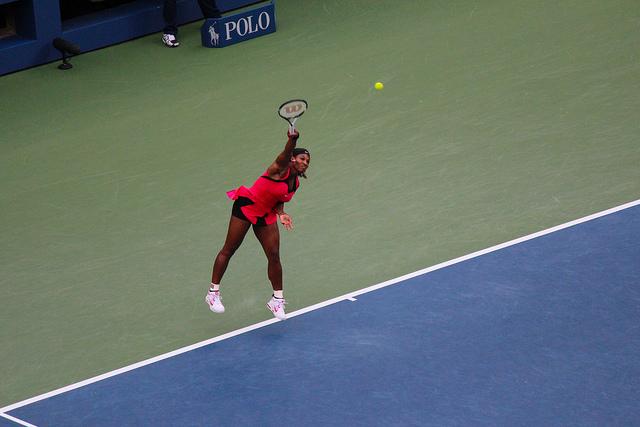Where is the shadow?
Concise answer only. Court. Who is winning?
Concise answer only. Unknown. Who is playing?
Short answer required. Serena williams. What is this sport?
Quick response, please. Tennis. Is the ball arriving or departing the racket of this athlete?
Short answer required. Departing. What color is the girl's dress?
Keep it brief. Red. 